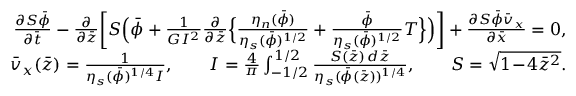Convert formula to latex. <formula><loc_0><loc_0><loc_500><loc_500>\begin{array} { r l r } & { \frac { \partial S \bar { \phi } } { \partial \bar { t } } - \frac { \partial } { \partial \bar { z } } \left [ S \left ( \bar { \phi } + \frac { 1 } { G I ^ { 2 } } \frac { \partial } { \partial \bar { z } } \left \{ \frac { \eta _ { n } ( \bar { \phi } ) } { \eta _ { s } ( \bar { \phi } ) ^ { 1 / 2 } } + \frac { \bar { \phi } } { \eta _ { s } ( \bar { \phi } ) ^ { 1 / 2 } } T \right \} \right ) \right ] + \frac { \partial S \bar { \phi } \bar { v } _ { x } } { \partial \bar { x } } = 0 , } \\ & { \bar { v } _ { x } ( \bar { z } ) = \frac { 1 } { \eta _ { s } ( \bar { \phi } ) ^ { 1 / 4 } I } , \quad I = \frac { 4 } { \pi } \int _ { - 1 / 2 } ^ { 1 / 2 } \frac { S ( \bar { z } ) \, d \bar { z } } { \eta _ { s } ( \bar { \phi } ( \bar { z } ) ) ^ { 1 / 4 } } , \quad S = \sqrt { 1 \, - \, 4 \bar { z } ^ { 2 } } . } \end{array}</formula> 